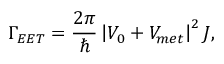Convert formula to latex. <formula><loc_0><loc_0><loc_500><loc_500>\Gamma _ { E E T } = \frac { 2 \pi } { } \left | V _ { 0 } + V _ { m e t } \right | ^ { 2 } J ,</formula> 